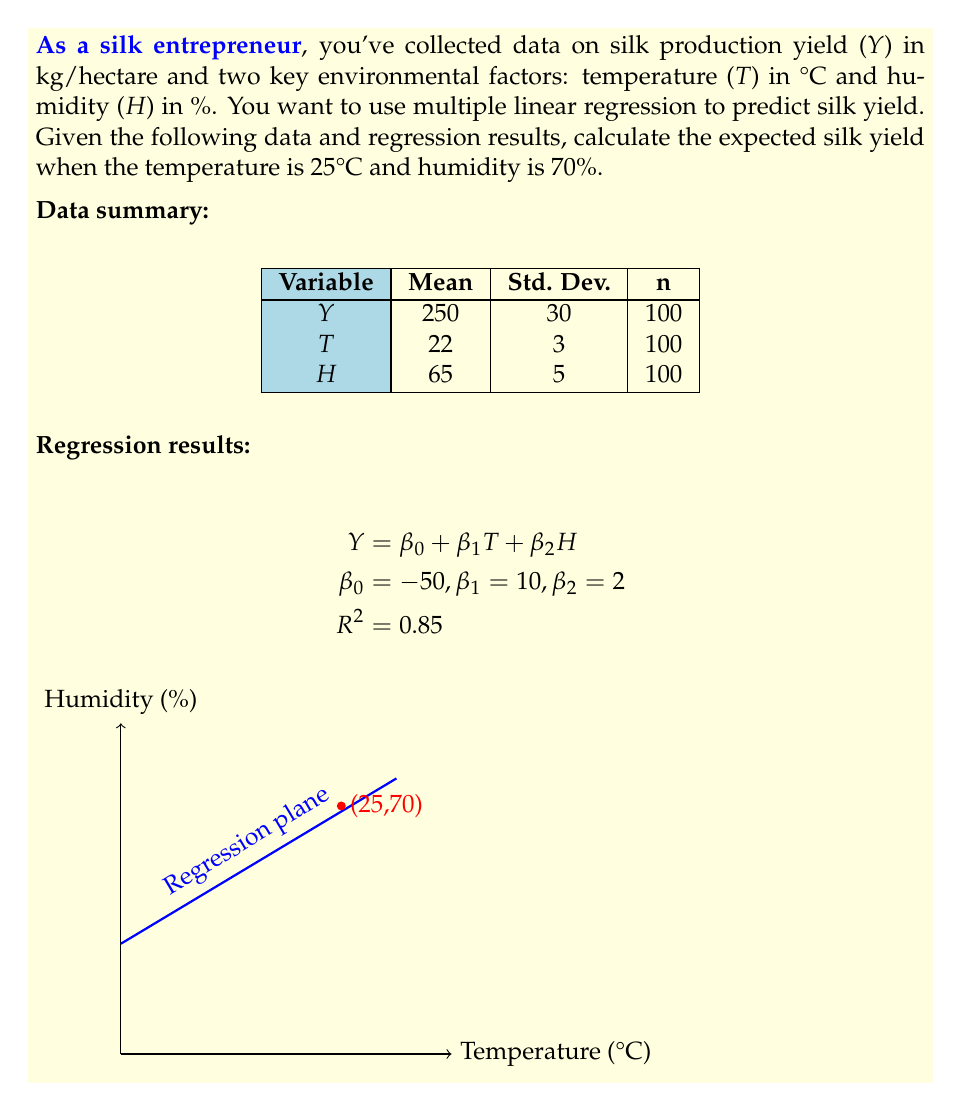Can you answer this question? To solve this problem, we'll follow these steps:

1) The multiple linear regression equation is given as:
   $$Y = \beta_0 + \beta_1T + \beta_2H$$

2) We're given the values of the coefficients:
   $$\beta_0 = -50, \beta_1 = 10, \beta_2 = 2$$

3) We need to predict Y when T = 25°C and H = 70%. Let's substitute these values into the equation:

   $$Y = -50 + 10(25) + 2(70)$$

4) Now, let's calculate step by step:
   
   $$Y = -50 + 250 + 140$$
   
   $$Y = 340$$

5) Therefore, the expected silk yield when the temperature is 25°C and humidity is 70% is 340 kg/hectare.

Note: The high R² value of 0.85 indicates that this model explains 85% of the variability in the silk yield, suggesting it's a good fit for prediction.
Answer: 340 kg/hectare 